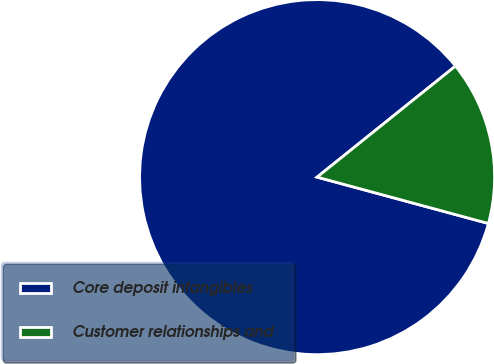Convert chart. <chart><loc_0><loc_0><loc_500><loc_500><pie_chart><fcel>Core deposit intangibles<fcel>Customer relationships and<nl><fcel>85.03%<fcel>14.97%<nl></chart> 